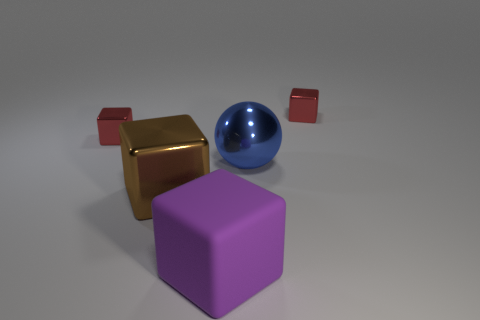Subtract 1 cubes. How many cubes are left? 3 Subtract all large rubber cubes. How many cubes are left? 3 Subtract all brown blocks. How many blocks are left? 3 Add 2 gray metallic blocks. How many objects exist? 7 Subtract all cyan cubes. Subtract all gray cylinders. How many cubes are left? 4 Subtract all balls. How many objects are left? 4 Subtract all large blue spheres. Subtract all small brown objects. How many objects are left? 4 Add 2 rubber things. How many rubber things are left? 3 Add 5 small blue cubes. How many small blue cubes exist? 5 Subtract 0 green balls. How many objects are left? 5 